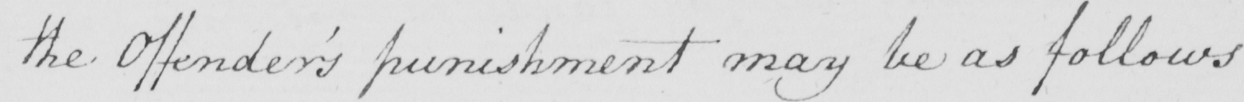Please transcribe the handwritten text in this image. the Offender ' s punishment may be as follows 